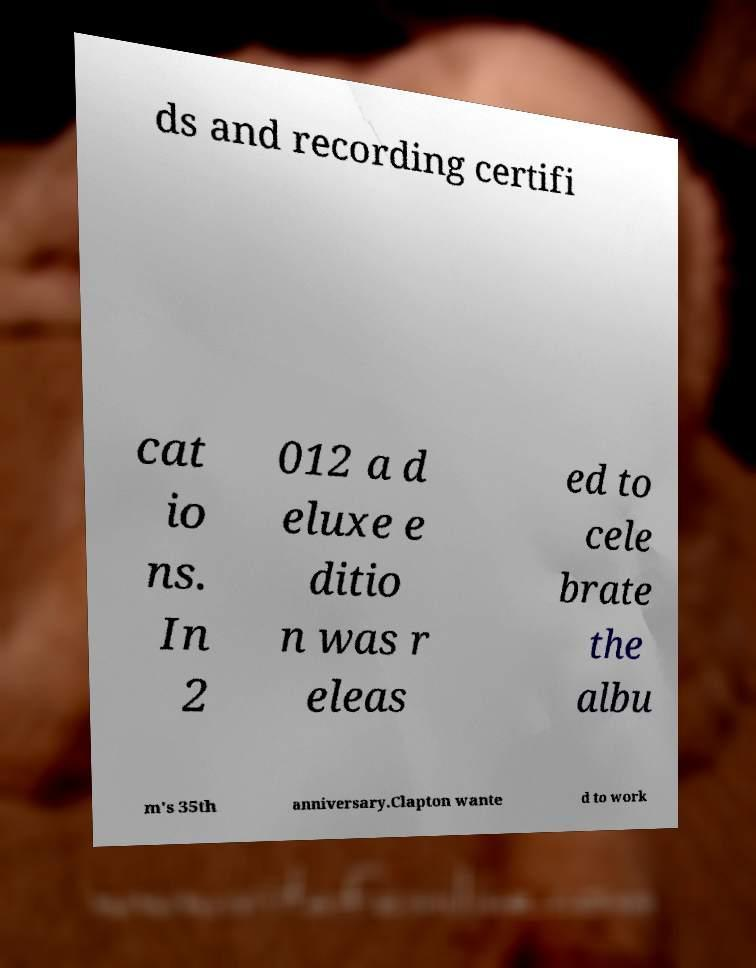Can you accurately transcribe the text from the provided image for me? ds and recording certifi cat io ns. In 2 012 a d eluxe e ditio n was r eleas ed to cele brate the albu m's 35th anniversary.Clapton wante d to work 